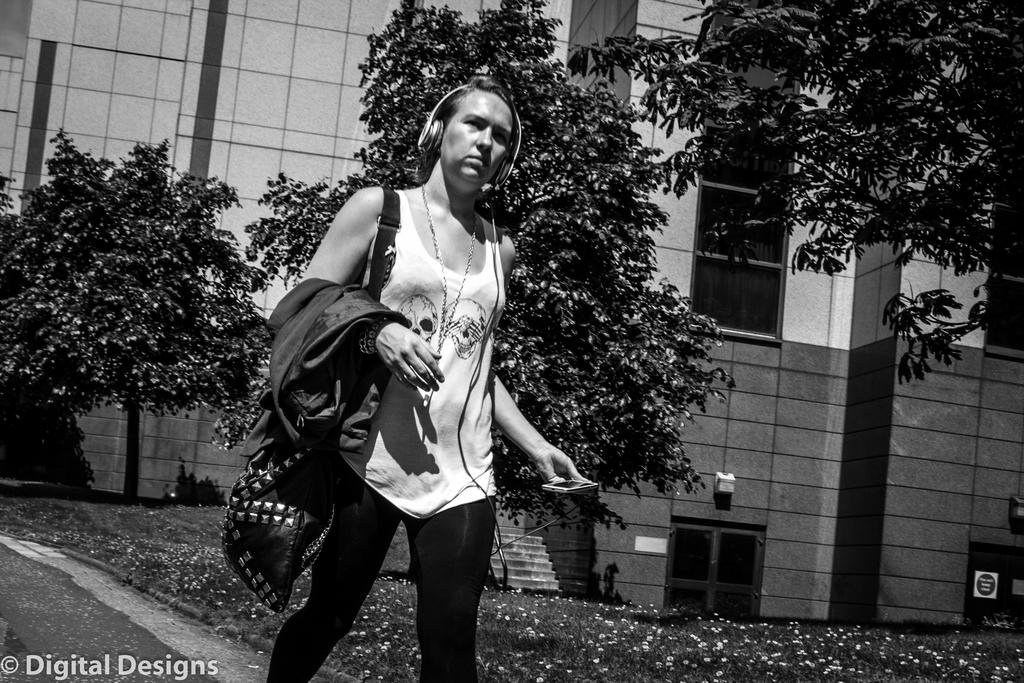Who is the main subject in the image? There is a lady in the image. What is the lady doing in the image? The lady is walking on a road in the image. What can be seen in the background of the image? There are trees and a building in the background of the image. Is there any text present in the image? Yes, there is some text in the bottom left corner of the image. What type of arch can be seen in the image? There is no arch present in the image. What substance is the lady walking on in the image? The substance the lady is walking on is a road, which is not a substance but a surface. 